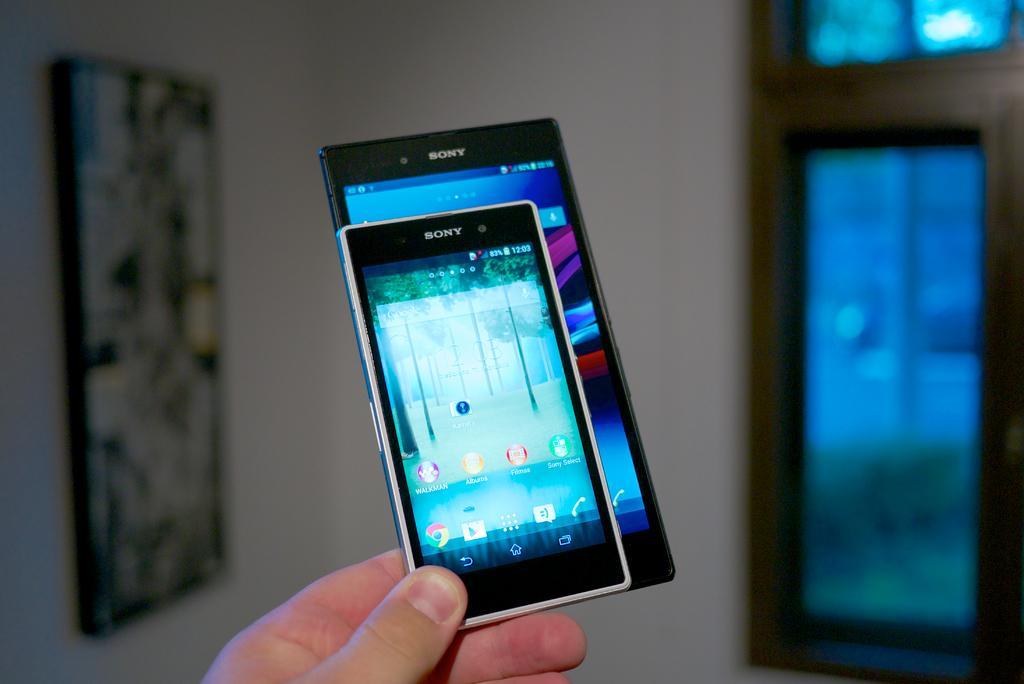<image>
Provide a brief description of the given image. A hand is showing the difference in size between two Sony cell phones. 